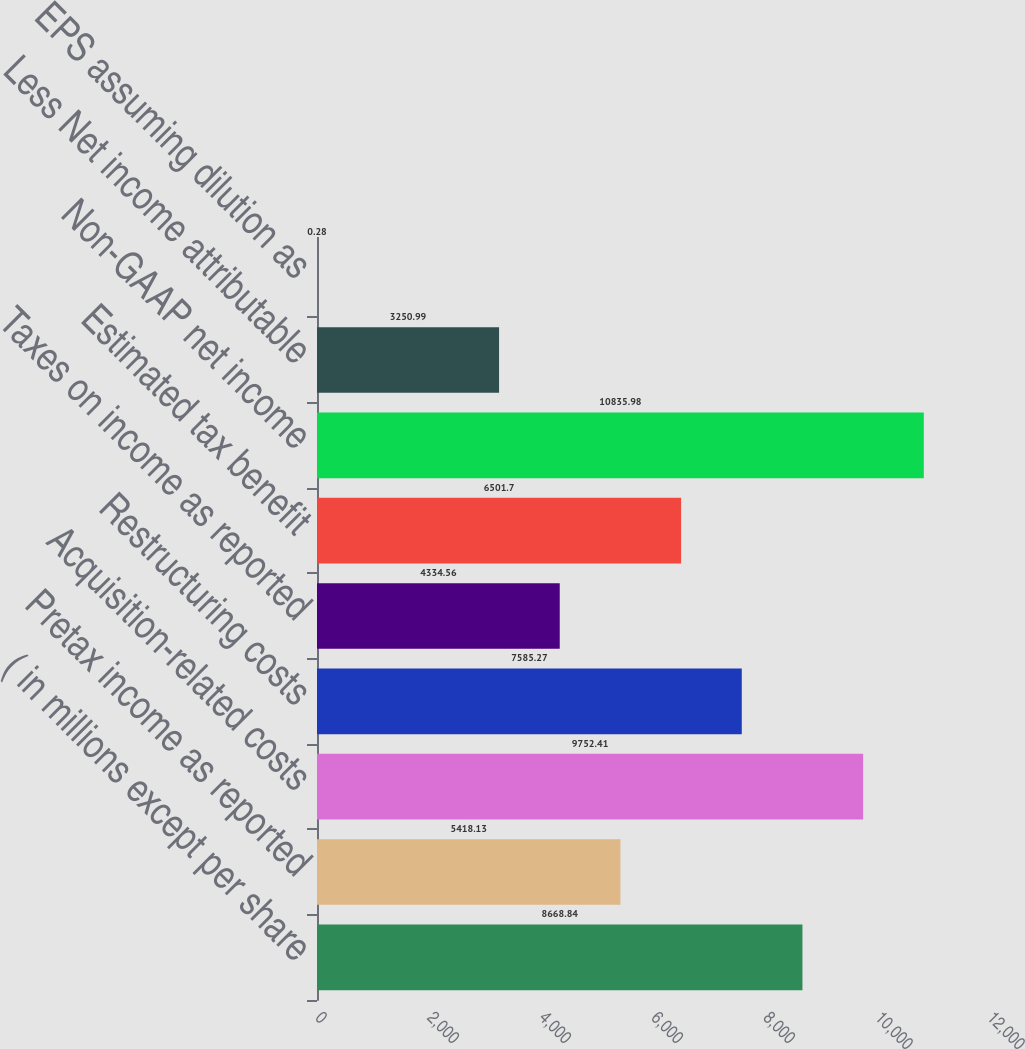Convert chart. <chart><loc_0><loc_0><loc_500><loc_500><bar_chart><fcel>( in millions except per share<fcel>Pretax income as reported<fcel>Acquisition-related costs<fcel>Restructuring costs<fcel>Taxes on income as reported<fcel>Estimated tax benefit<fcel>Non-GAAP net income<fcel>Less Net income attributable<fcel>EPS assuming dilution as<nl><fcel>8668.84<fcel>5418.13<fcel>9752.41<fcel>7585.27<fcel>4334.56<fcel>6501.7<fcel>10836<fcel>3250.99<fcel>0.28<nl></chart> 